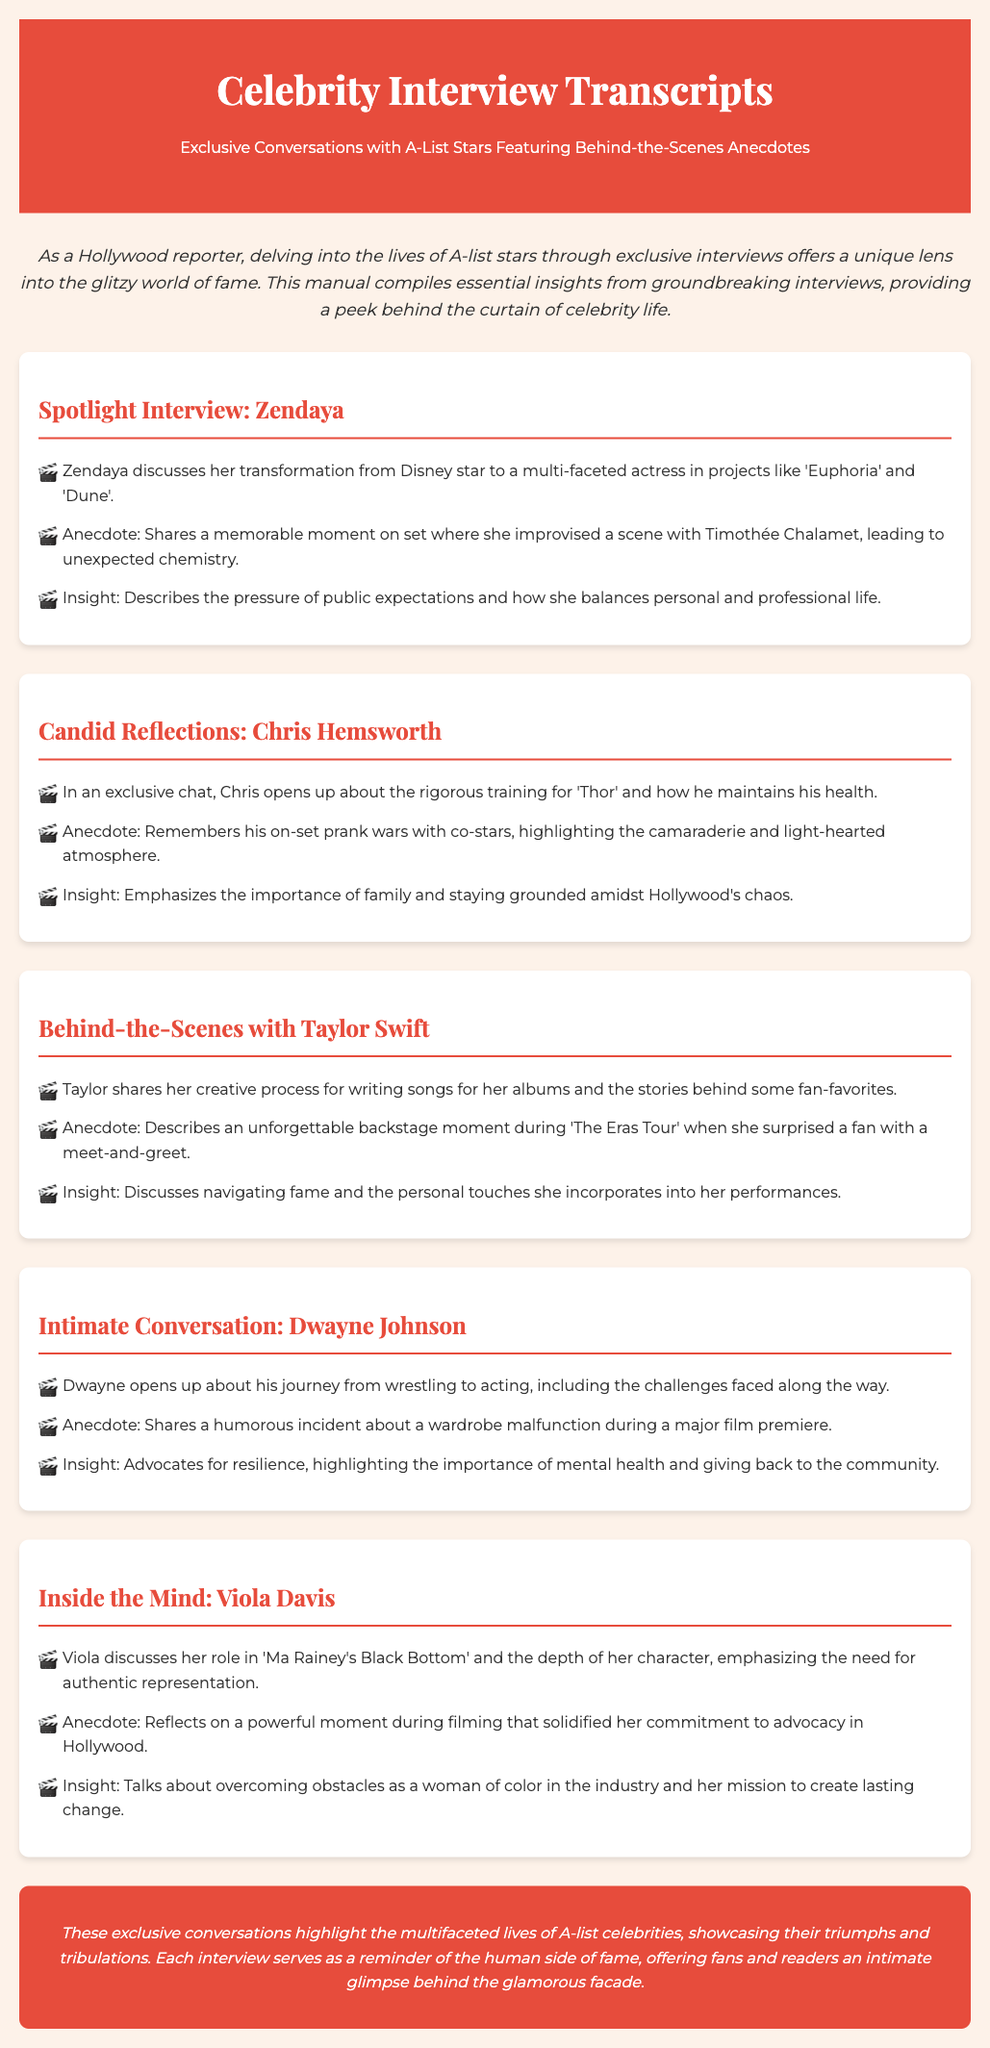What is the title of the manual? The title of the manual is found in the header section, which states, "Celebrity Interview Transcripts."
Answer: Celebrity Interview Transcripts Who is featured in the spotlight interview? The spotlight interview section specifically highlights "Zendaya."
Answer: Zendaya What type of anecdote does Chris Hemsworth share? The anecdote in the section about Chris Hemsworth mentions "on-set prank wars."
Answer: on-set prank wars Which album's creative process does Taylor Swift discuss? Taylor Swift discusses the creative process for "her albums," without specifying a title in the document.
Answer: her albums What is Dwayne Johnson's journey from and to which profession? The document mentions Dwayne Johnson's journey from "wrestling" to "acting."
Answer: wrestling to acting What common theme is highlighted in Viola Davis's section? Viola Davis emphasizes "authentic representation" in her section.
Answer: authentic representation How does Zendaya describe public expectations? Zendaya mentions the "pressure of public expectations" in her insights.
Answer: pressure of public expectations What does the conclusion emphasize about fame? The conclusion highlights the "human side of fame."
Answer: human side of fame What is the general focus of the manual? The manual focuses on "exclusive conversations" with A-list stars.
Answer: exclusive conversations 